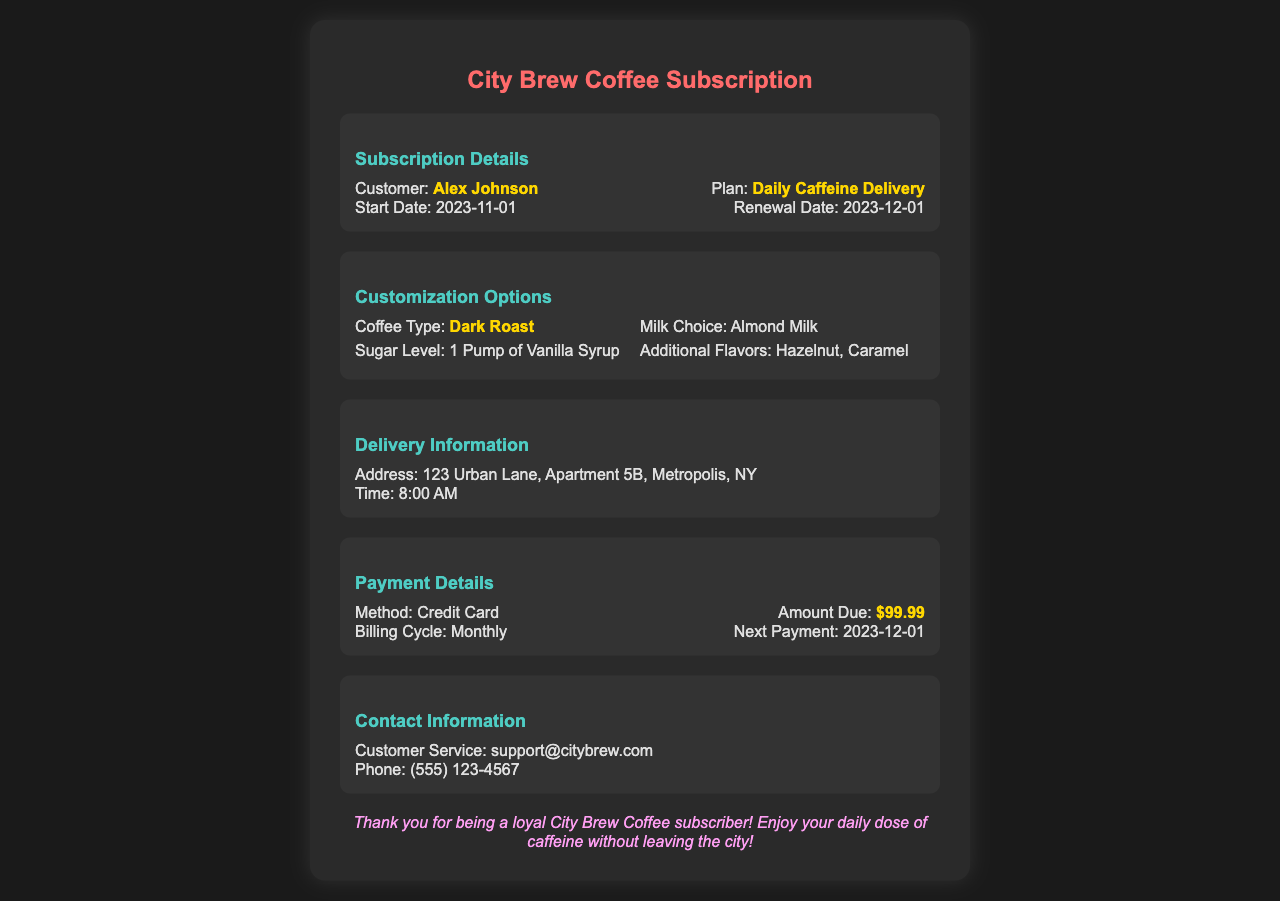What is the customer's name? The customer's name is listed in the subscription details section of the document, specifically noted as Alex Johnson.
Answer: Alex Johnson What is the start date of the subscription? The start date can be found in the subscription details section, which indicates it is 2023-11-01.
Answer: 2023-11-01 What type of coffee is selected? The coffee type is mentioned under the customization options section, which states it is Dark Roast.
Answer: Dark Roast What is the payment amount due? The payment amount is specified in the payment details section, indicating the total is $99.99.
Answer: $99.99 What is the delivery address? The delivery address is listed in the delivery information section, specifically at 123 Urban Lane, Apartment 5B, Metropolis, NY.
Answer: 123 Urban Lane, Apartment 5B, Metropolis, NY When is the next payment due? The next payment date is mentioned in the payment details section of the document, which is 2023-12-01.
Answer: 2023-12-01 What milk choice was customized? The milk choice is outlined in the customization options section, specifically stating Almond Milk.
Answer: Almond Milk What flavors were added? The additional flavors can be found in the customization options section, where it lists Hazelnut and Caramel.
Answer: Hazelnut, Caramel What time is the coffee delivery scheduled for? The scheduled delivery time is indicated in the delivery information section, which states it is 8:00 AM.
Answer: 8:00 AM 